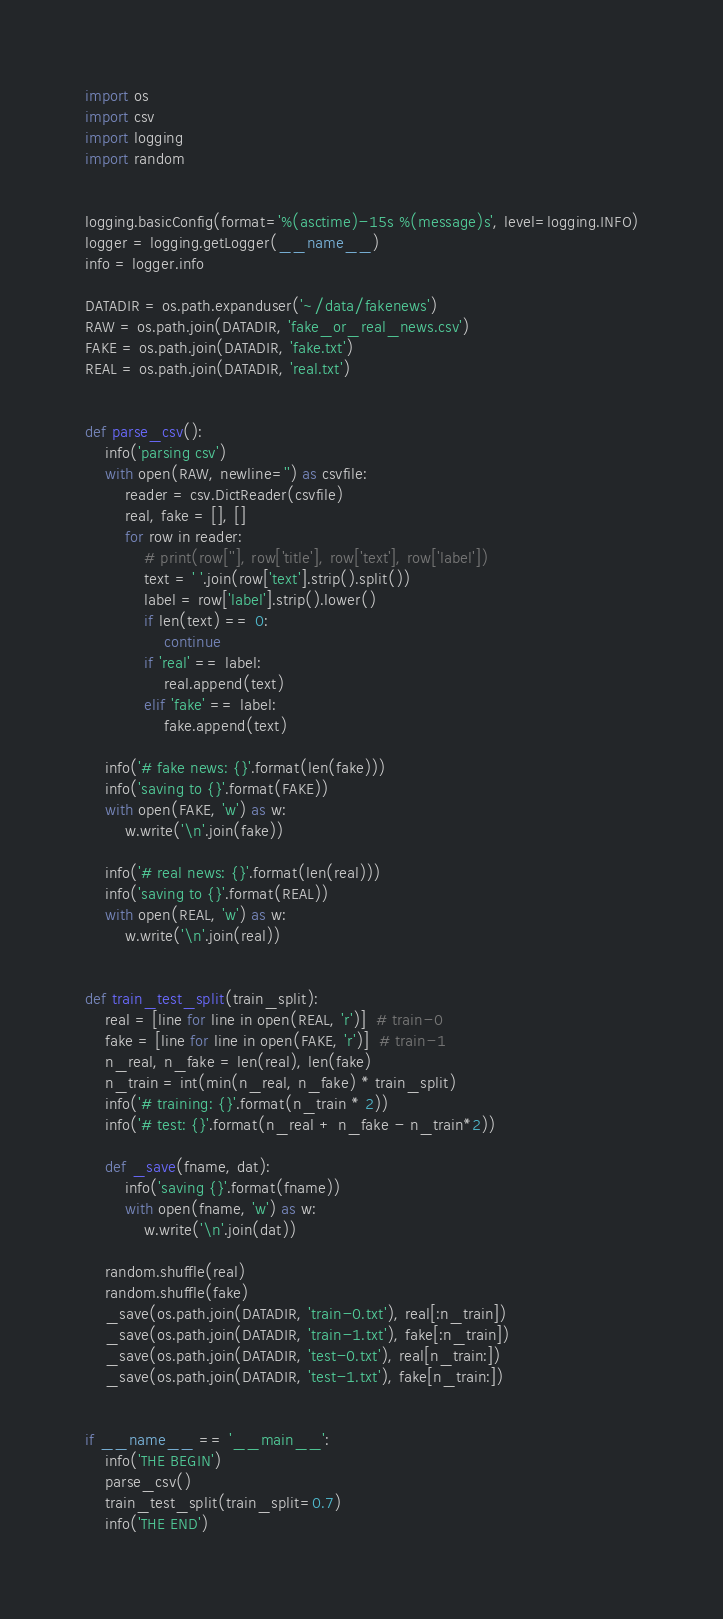<code> <loc_0><loc_0><loc_500><loc_500><_Python_>import os
import csv
import logging
import random


logging.basicConfig(format='%(asctime)-15s %(message)s', level=logging.INFO)
logger = logging.getLogger(__name__)
info = logger.info

DATADIR = os.path.expanduser('~/data/fakenews')
RAW = os.path.join(DATADIR, 'fake_or_real_news.csv')
FAKE = os.path.join(DATADIR, 'fake.txt')
REAL = os.path.join(DATADIR, 'real.txt')


def parse_csv():
    info('parsing csv')
    with open(RAW, newline='') as csvfile:
        reader = csv.DictReader(csvfile)
        real, fake = [], []
        for row in reader:
            # print(row[''], row['title'], row['text'], row['label'])
            text = ' '.join(row['text'].strip().split())
            label = row['label'].strip().lower()
            if len(text) == 0:
                continue
            if 'real' == label:
                real.append(text)
            elif 'fake' == label:
                fake.append(text)

    info('# fake news: {}'.format(len(fake)))
    info('saving to {}'.format(FAKE))
    with open(FAKE, 'w') as w:
        w.write('\n'.join(fake))

    info('# real news: {}'.format(len(real)))
    info('saving to {}'.format(REAL))
    with open(REAL, 'w') as w:
        w.write('\n'.join(real))


def train_test_split(train_split):
    real = [line for line in open(REAL, 'r')]  # train-0
    fake = [line for line in open(FAKE, 'r')]  # train-1
    n_real, n_fake = len(real), len(fake)
    n_train = int(min(n_real, n_fake) * train_split)
    info('# training: {}'.format(n_train * 2))
    info('# test: {}'.format(n_real + n_fake - n_train*2))

    def _save(fname, dat):
        info('saving {}'.format(fname))
        with open(fname, 'w') as w:
            w.write('\n'.join(dat))

    random.shuffle(real)
    random.shuffle(fake)
    _save(os.path.join(DATADIR, 'train-0.txt'), real[:n_train])
    _save(os.path.join(DATADIR, 'train-1.txt'), fake[:n_train])
    _save(os.path.join(DATADIR, 'test-0.txt'), real[n_train:])
    _save(os.path.join(DATADIR, 'test-1.txt'), fake[n_train:])


if __name__ == '__main__':
    info('THE BEGIN')
    parse_csv()
    train_test_split(train_split=0.7)
    info('THE END')
</code> 